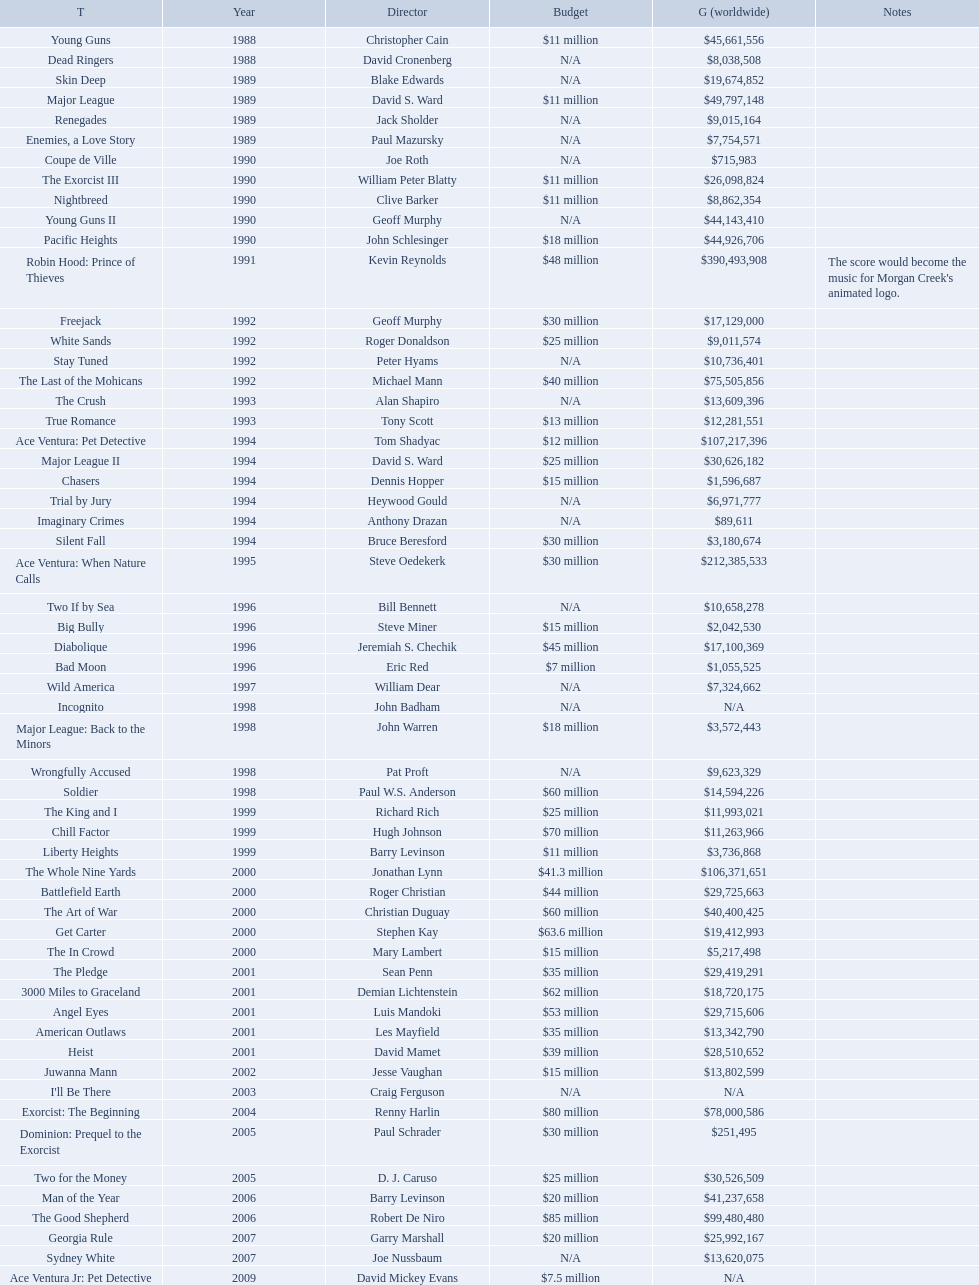What was the only movie with a 48 million dollar budget? Robin Hood: Prince of Thieves. 